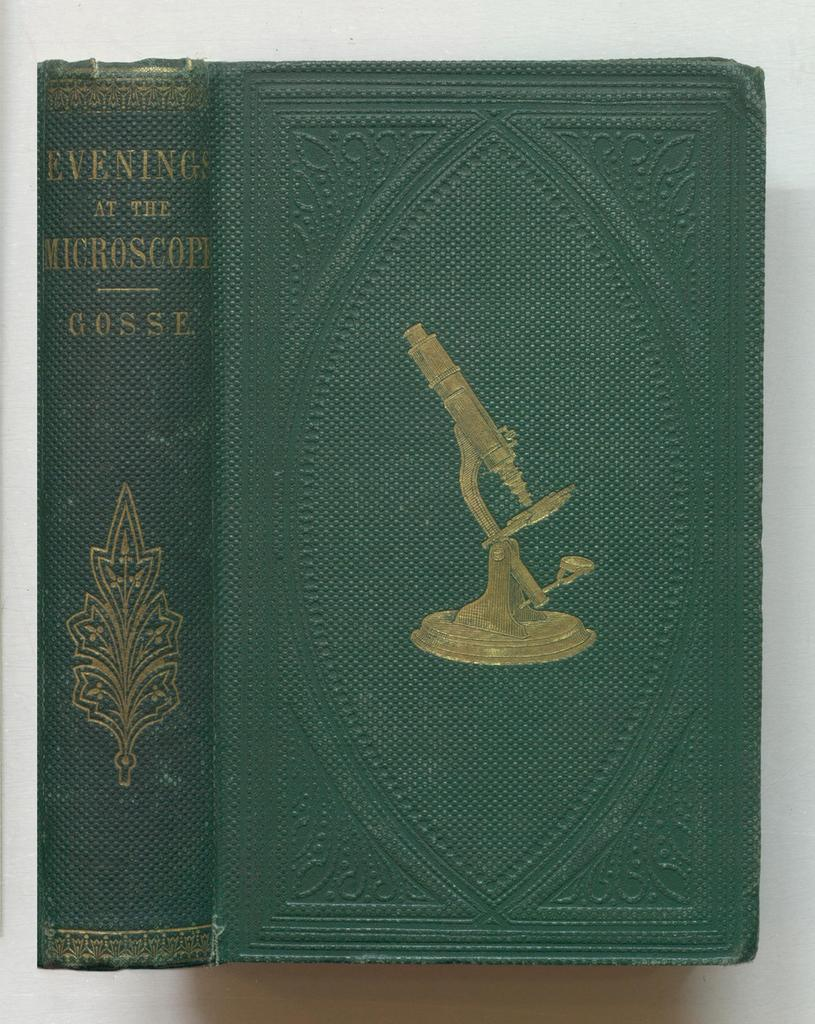<image>
Share a concise interpretation of the image provided. green hardcover book titled evening at the microscope with a drawing of a microscope on the front 